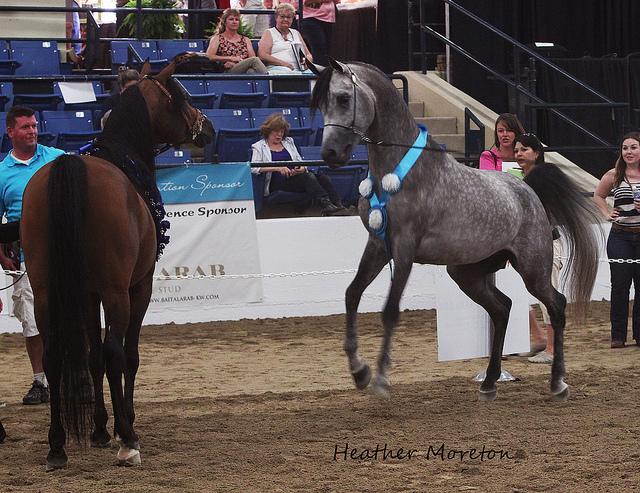Are these circus horses?
Write a very short answer. Yes. What color is the sash around the gray horse?
Give a very brief answer. Blue. What color are the seats?
Be succinct. Blue. 